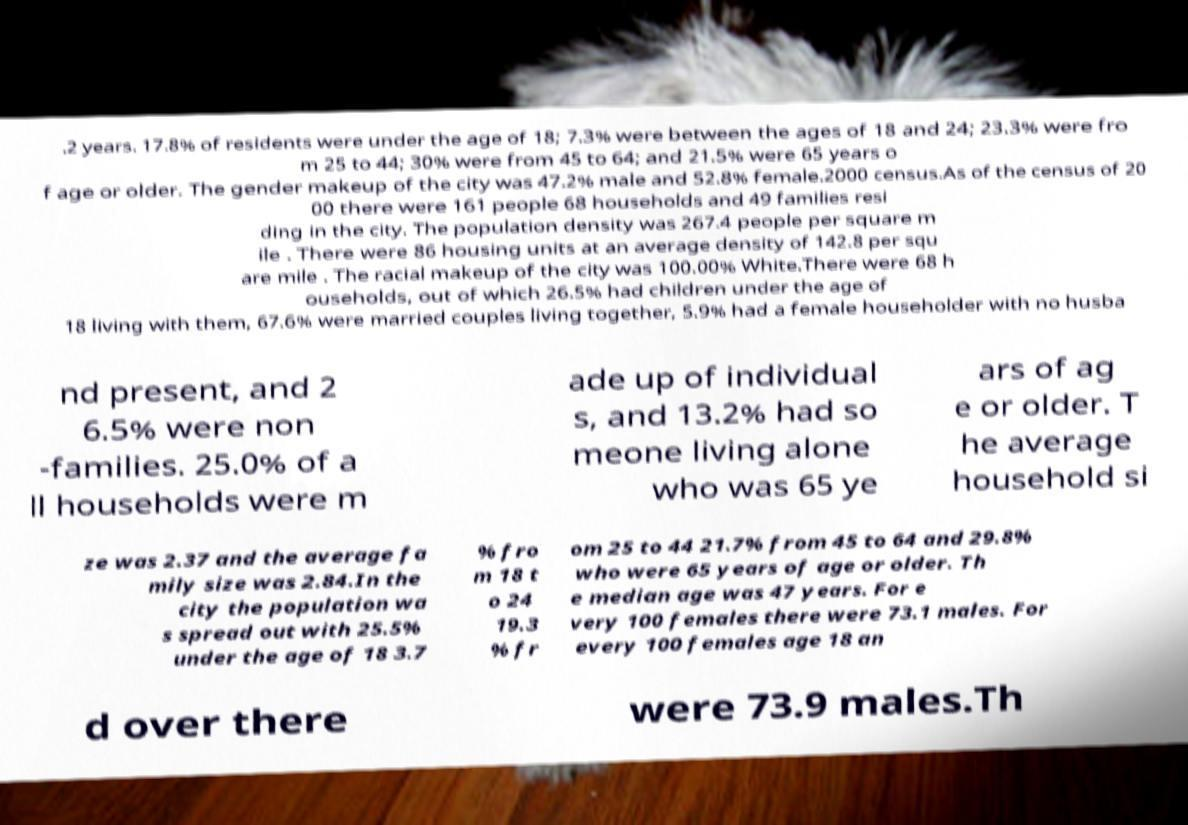Could you extract and type out the text from this image? .2 years. 17.8% of residents were under the age of 18; 7.3% were between the ages of 18 and 24; 23.3% were fro m 25 to 44; 30% were from 45 to 64; and 21.5% were 65 years o f age or older. The gender makeup of the city was 47.2% male and 52.8% female.2000 census.As of the census of 20 00 there were 161 people 68 households and 49 families resi ding in the city. The population density was 267.4 people per square m ile . There were 86 housing units at an average density of 142.8 per squ are mile . The racial makeup of the city was 100.00% White.There were 68 h ouseholds, out of which 26.5% had children under the age of 18 living with them, 67.6% were married couples living together, 5.9% had a female householder with no husba nd present, and 2 6.5% were non -families. 25.0% of a ll households were m ade up of individual s, and 13.2% had so meone living alone who was 65 ye ars of ag e or older. T he average household si ze was 2.37 and the average fa mily size was 2.84.In the city the population wa s spread out with 25.5% under the age of 18 3.7 % fro m 18 t o 24 19.3 % fr om 25 to 44 21.7% from 45 to 64 and 29.8% who were 65 years of age or older. Th e median age was 47 years. For e very 100 females there were 73.1 males. For every 100 females age 18 an d over there were 73.9 males.Th 